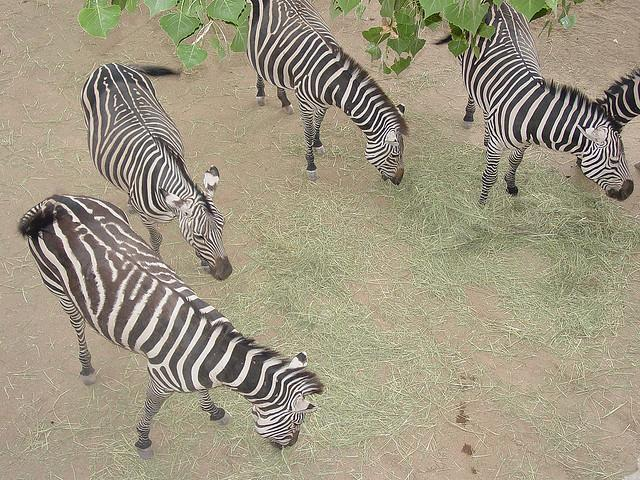How many zebras are standing on the hay below the tree?

Choices:
A) four
B) five
C) one
D) three four 